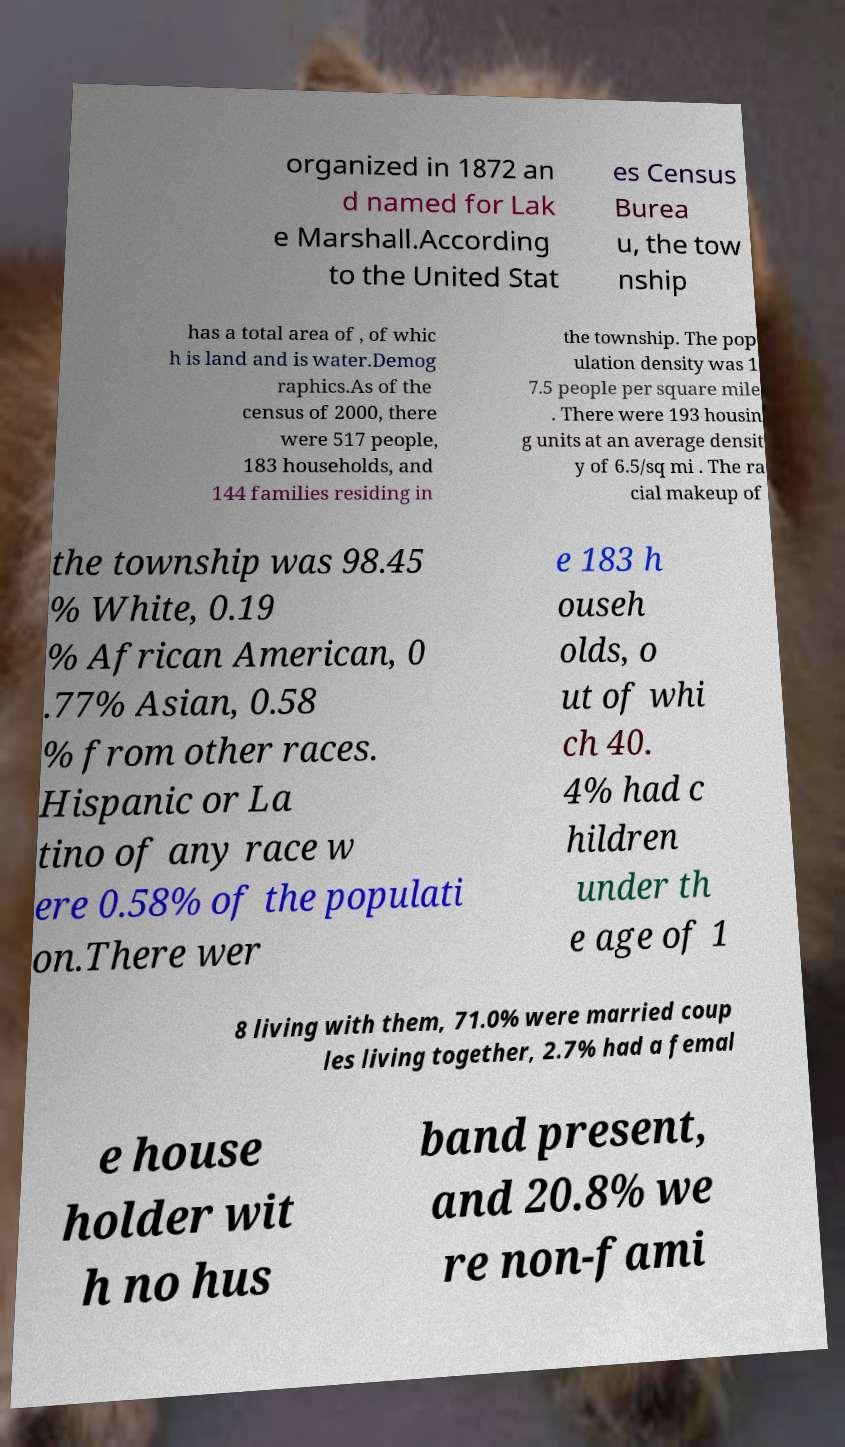There's text embedded in this image that I need extracted. Can you transcribe it verbatim? organized in 1872 an d named for Lak e Marshall.According to the United Stat es Census Burea u, the tow nship has a total area of , of whic h is land and is water.Demog raphics.As of the census of 2000, there were 517 people, 183 households, and 144 families residing in the township. The pop ulation density was 1 7.5 people per square mile . There were 193 housin g units at an average densit y of 6.5/sq mi . The ra cial makeup of the township was 98.45 % White, 0.19 % African American, 0 .77% Asian, 0.58 % from other races. Hispanic or La tino of any race w ere 0.58% of the populati on.There wer e 183 h ouseh olds, o ut of whi ch 40. 4% had c hildren under th e age of 1 8 living with them, 71.0% were married coup les living together, 2.7% had a femal e house holder wit h no hus band present, and 20.8% we re non-fami 